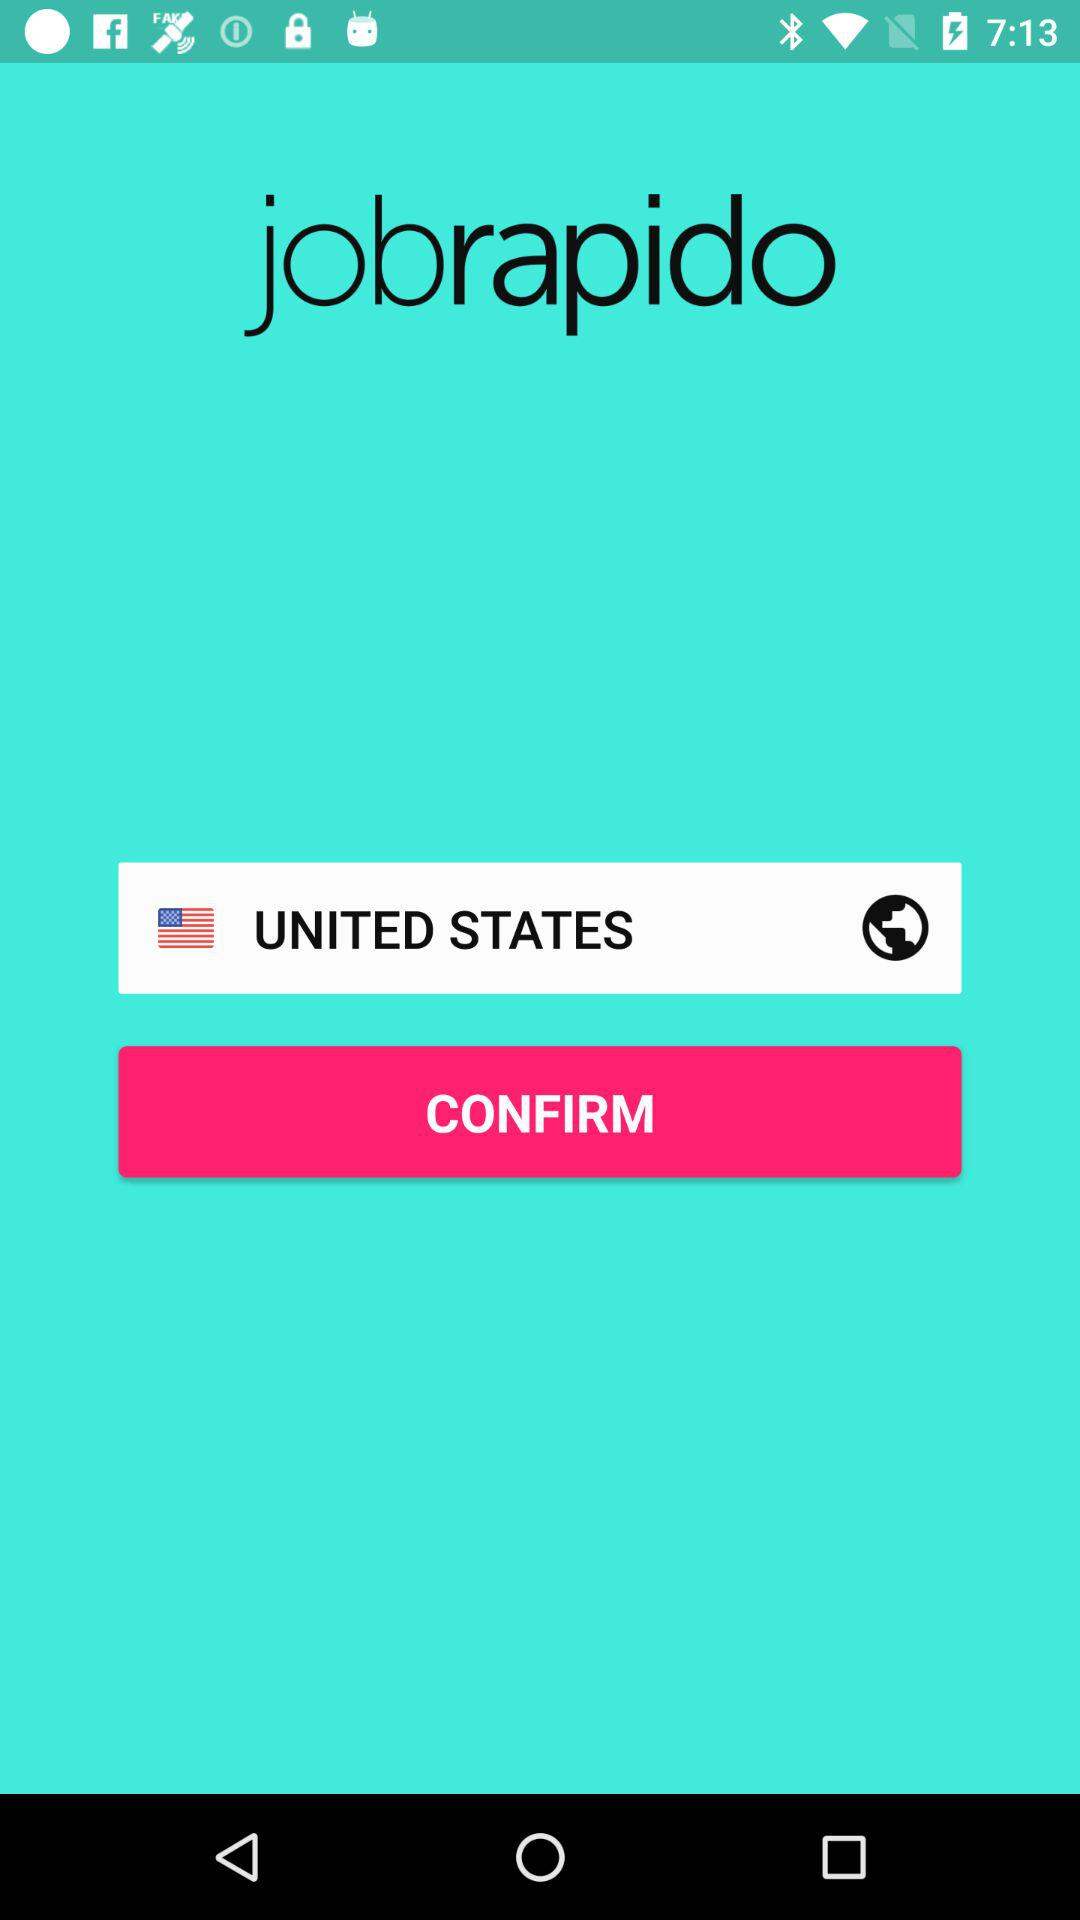What is the name of the application? The name of the application is "jobrapido". 